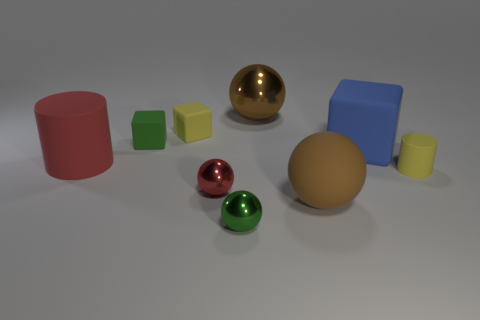What color is the ball that is behind the object to the left of the cube that is to the left of the small yellow matte cube?
Give a very brief answer. Brown. What number of other objects are there of the same material as the tiny yellow cube?
Make the answer very short. 5. There is a green thing in front of the red sphere; is it the same shape as the tiny green rubber thing?
Your answer should be very brief. No. What number of tiny things are either matte cubes or matte cylinders?
Provide a succinct answer. 3. Are there an equal number of red metallic balls that are to the left of the big metallic sphere and big brown rubber objects that are in front of the red matte thing?
Your response must be concise. Yes. How many other objects are the same color as the tiny cylinder?
Offer a terse response. 1. There is a big block; is it the same color as the matte cylinder that is on the right side of the green metallic ball?
Your answer should be compact. No. How many brown things are either small spheres or cubes?
Your answer should be compact. 0. Are there an equal number of small green objects that are behind the blue matte thing and big blue blocks?
Give a very brief answer. Yes. Are there any other things that have the same size as the red metallic thing?
Provide a succinct answer. Yes. 